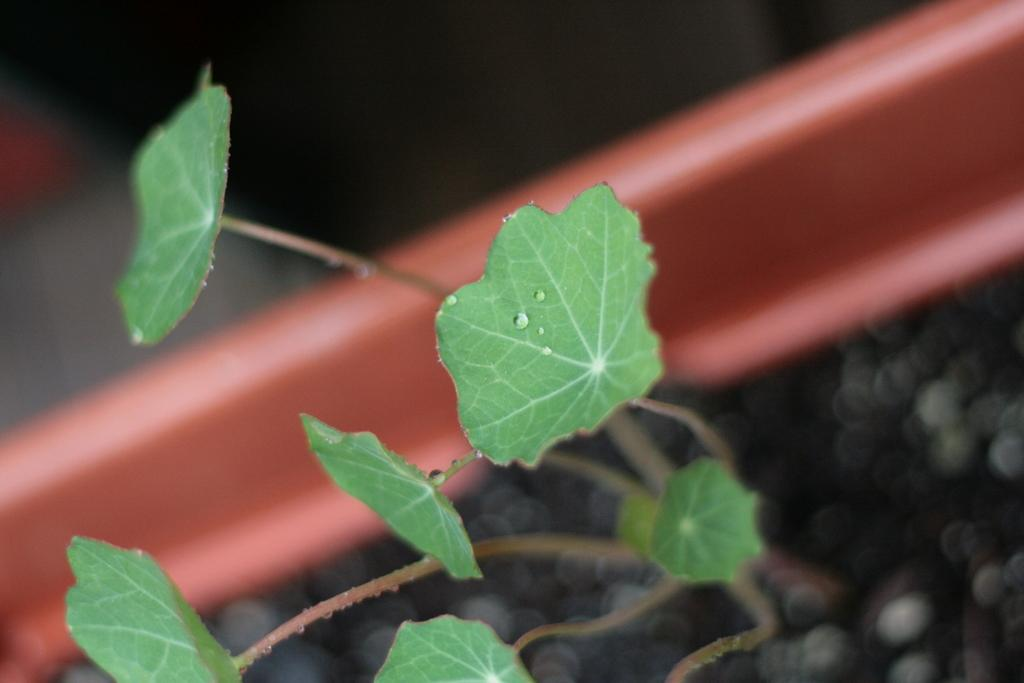What is present in the image? There is a plant in the image. Can you describe the plant in more detail? There are water drops on a leaf of the plant. What can be observed about the background of the image? The background of the image is blurred. What reward does the goose receive for its contribution to the image? There is no goose present in the image, so it cannot receive any reward. 